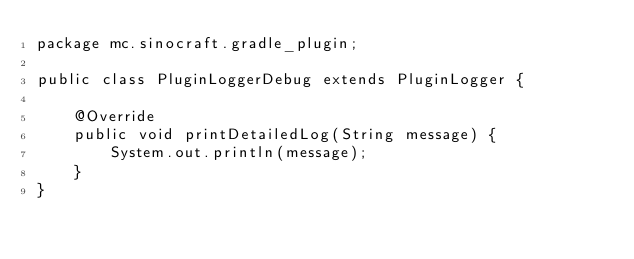<code> <loc_0><loc_0><loc_500><loc_500><_Java_>package mc.sinocraft.gradle_plugin;

public class PluginLoggerDebug extends PluginLogger {

    @Override
    public void printDetailedLog(String message) {
        System.out.println(message);
    }
}
</code> 